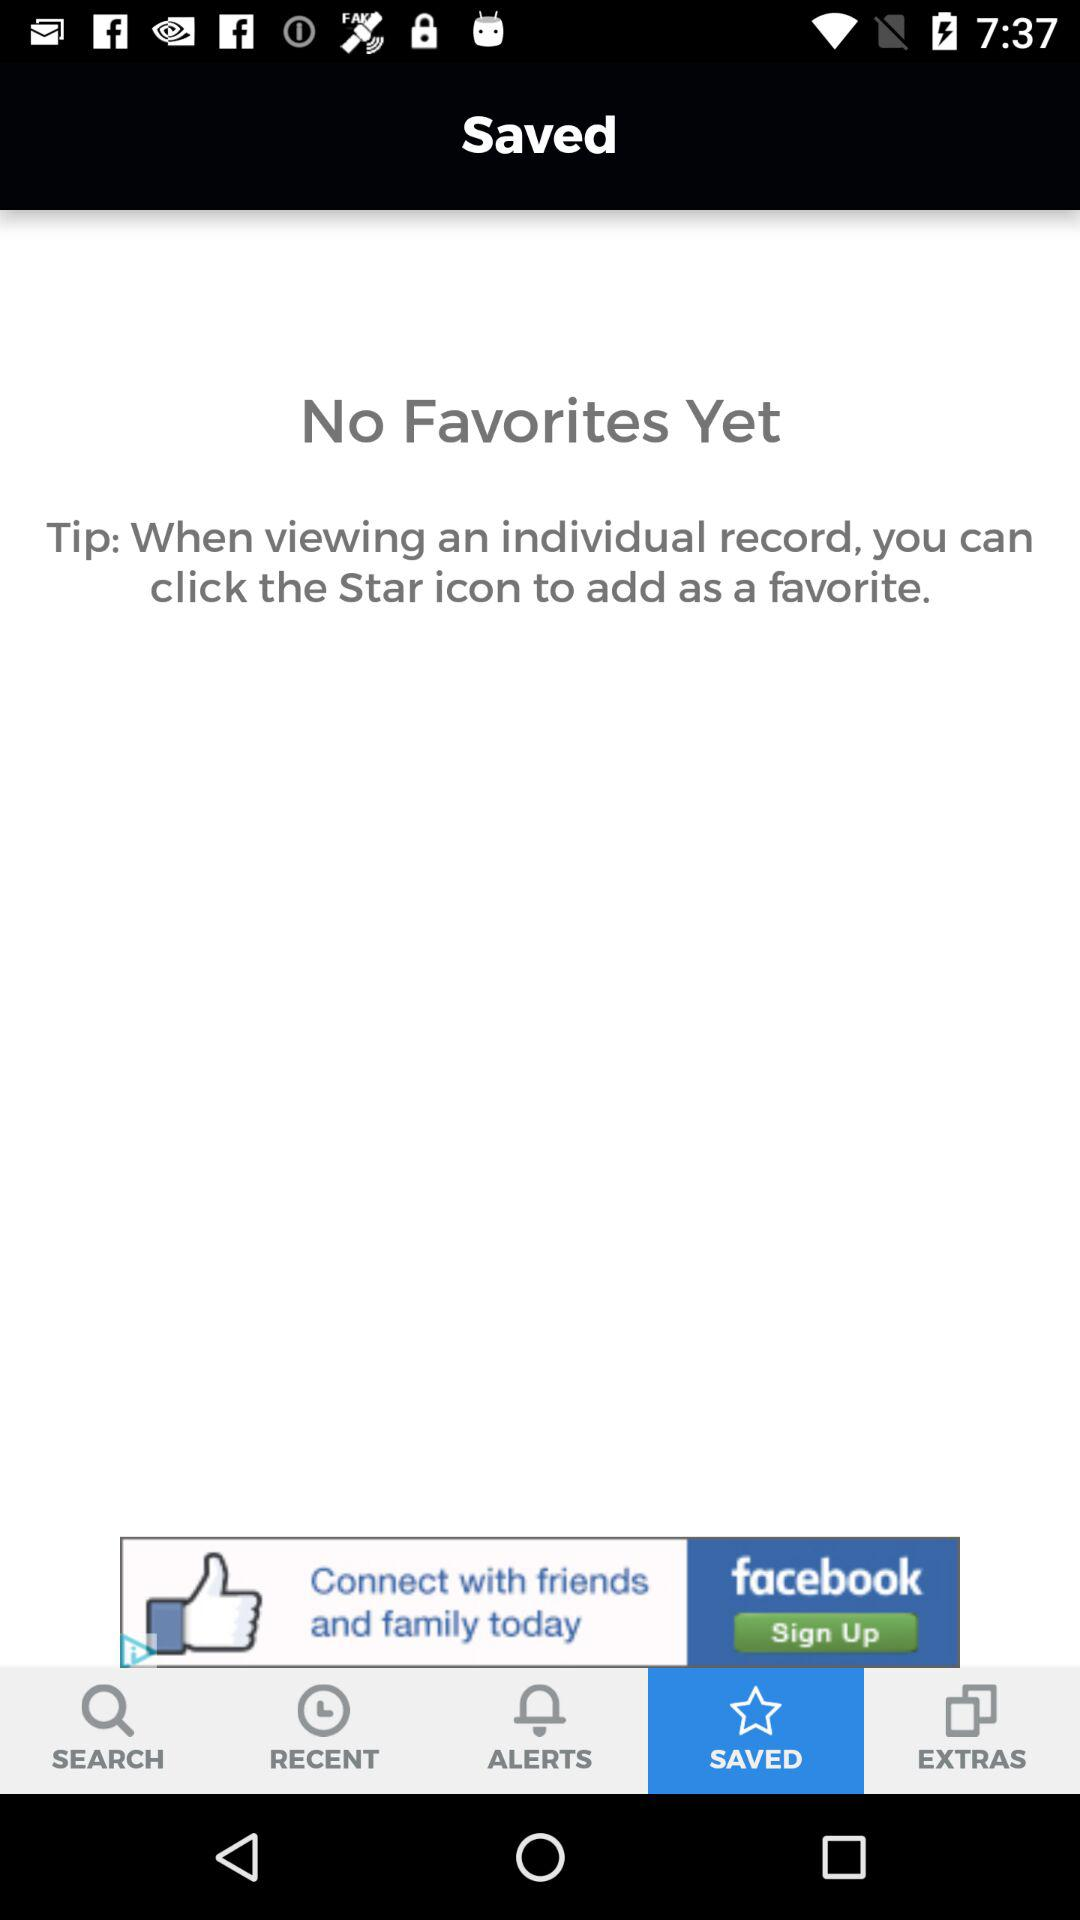Which tab is selected? The selected tab is "SAVED". 